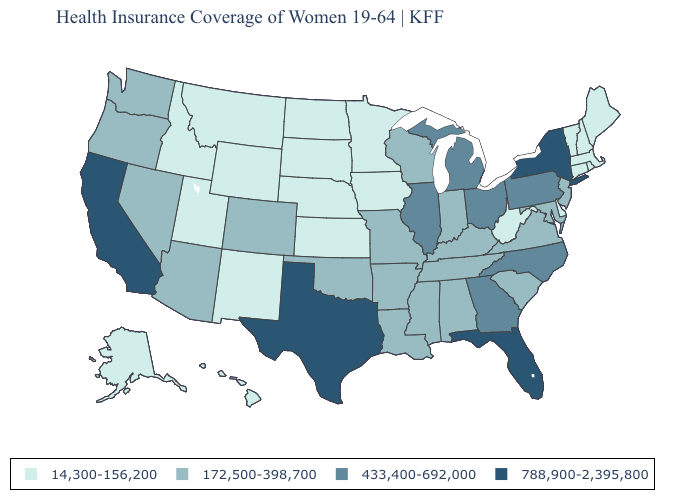Which states have the lowest value in the South?
Be succinct. Delaware, West Virginia. Name the states that have a value in the range 433,400-692,000?
Write a very short answer. Georgia, Illinois, Michigan, North Carolina, Ohio, Pennsylvania. What is the value of New Mexico?
Quick response, please. 14,300-156,200. Does the map have missing data?
Answer briefly. No. What is the value of Louisiana?
Write a very short answer. 172,500-398,700. What is the value of Nevada?
Keep it brief. 172,500-398,700. What is the value of Montana?
Concise answer only. 14,300-156,200. How many symbols are there in the legend?
Keep it brief. 4. What is the value of Oklahoma?
Quick response, please. 172,500-398,700. Does Nebraska have the highest value in the MidWest?
Be succinct. No. Which states have the lowest value in the USA?
Concise answer only. Alaska, Connecticut, Delaware, Hawaii, Idaho, Iowa, Kansas, Maine, Massachusetts, Minnesota, Montana, Nebraska, New Hampshire, New Mexico, North Dakota, Rhode Island, South Dakota, Utah, Vermont, West Virginia, Wyoming. Does the map have missing data?
Short answer required. No. What is the value of Colorado?
Write a very short answer. 172,500-398,700. What is the value of Virginia?
Concise answer only. 172,500-398,700. Does Kansas have the highest value in the USA?
Quick response, please. No. 